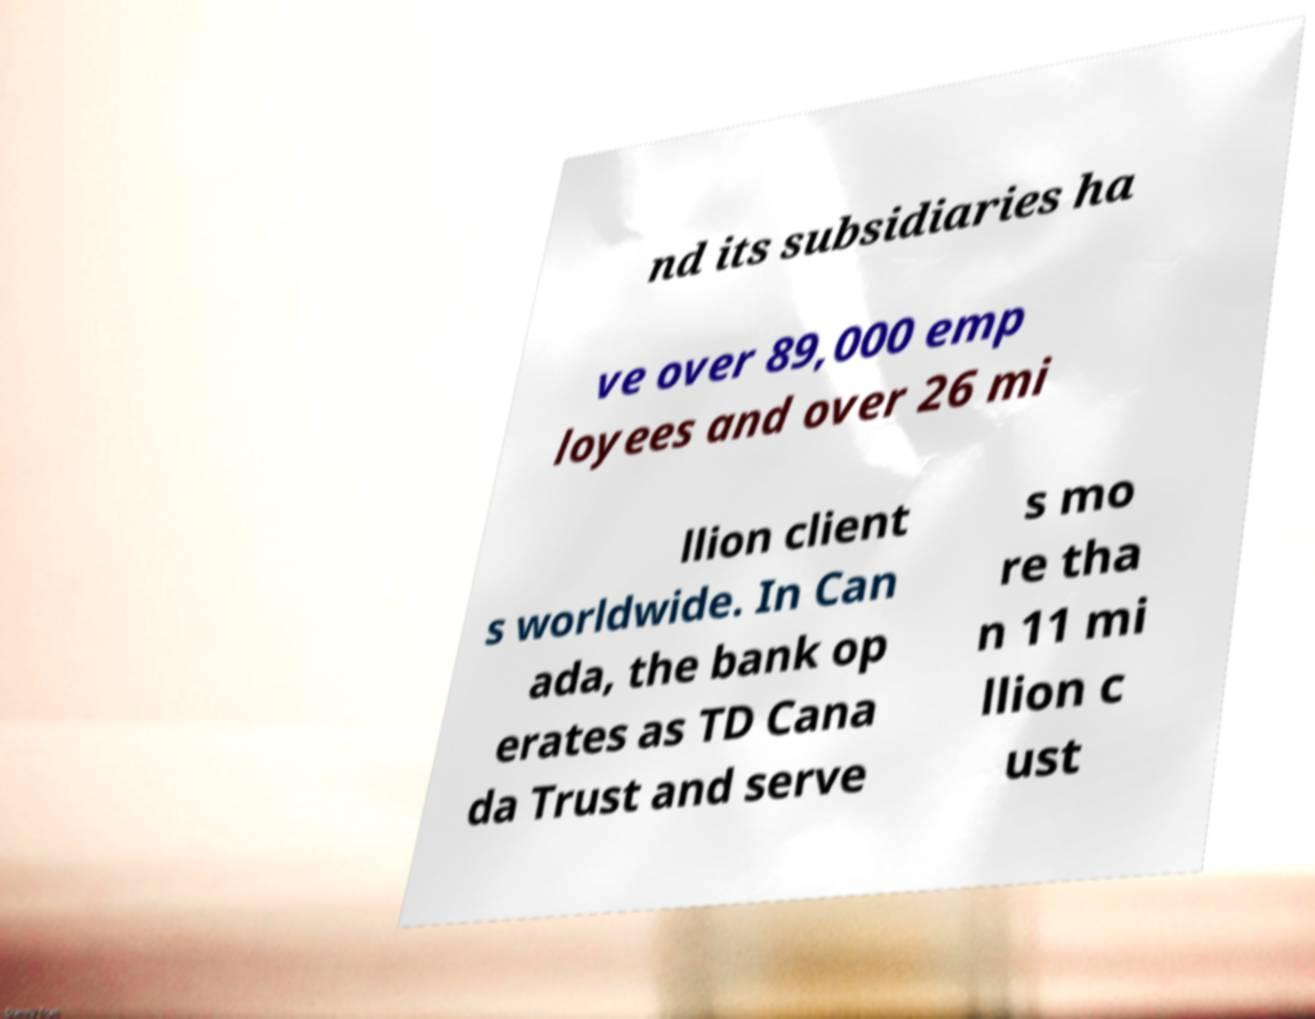Could you extract and type out the text from this image? nd its subsidiaries ha ve over 89,000 emp loyees and over 26 mi llion client s worldwide. In Can ada, the bank op erates as TD Cana da Trust and serve s mo re tha n 11 mi llion c ust 